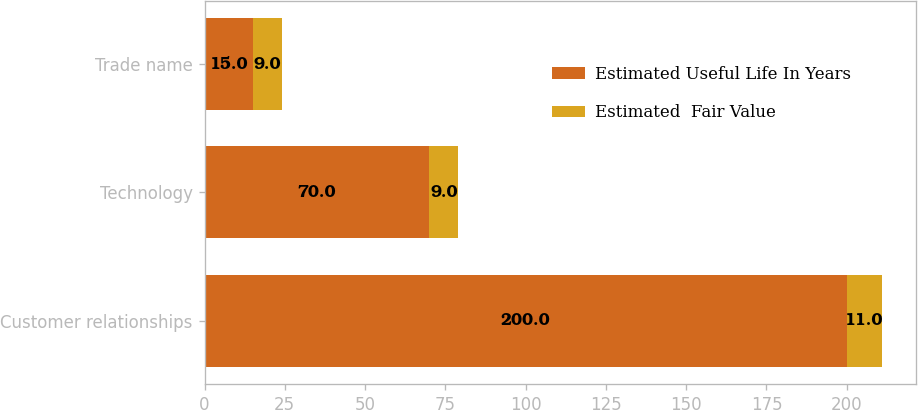Convert chart. <chart><loc_0><loc_0><loc_500><loc_500><stacked_bar_chart><ecel><fcel>Customer relationships<fcel>Technology<fcel>Trade name<nl><fcel>Estimated Useful Life In Years<fcel>200<fcel>70<fcel>15<nl><fcel>Estimated  Fair Value<fcel>11<fcel>9<fcel>9<nl></chart> 